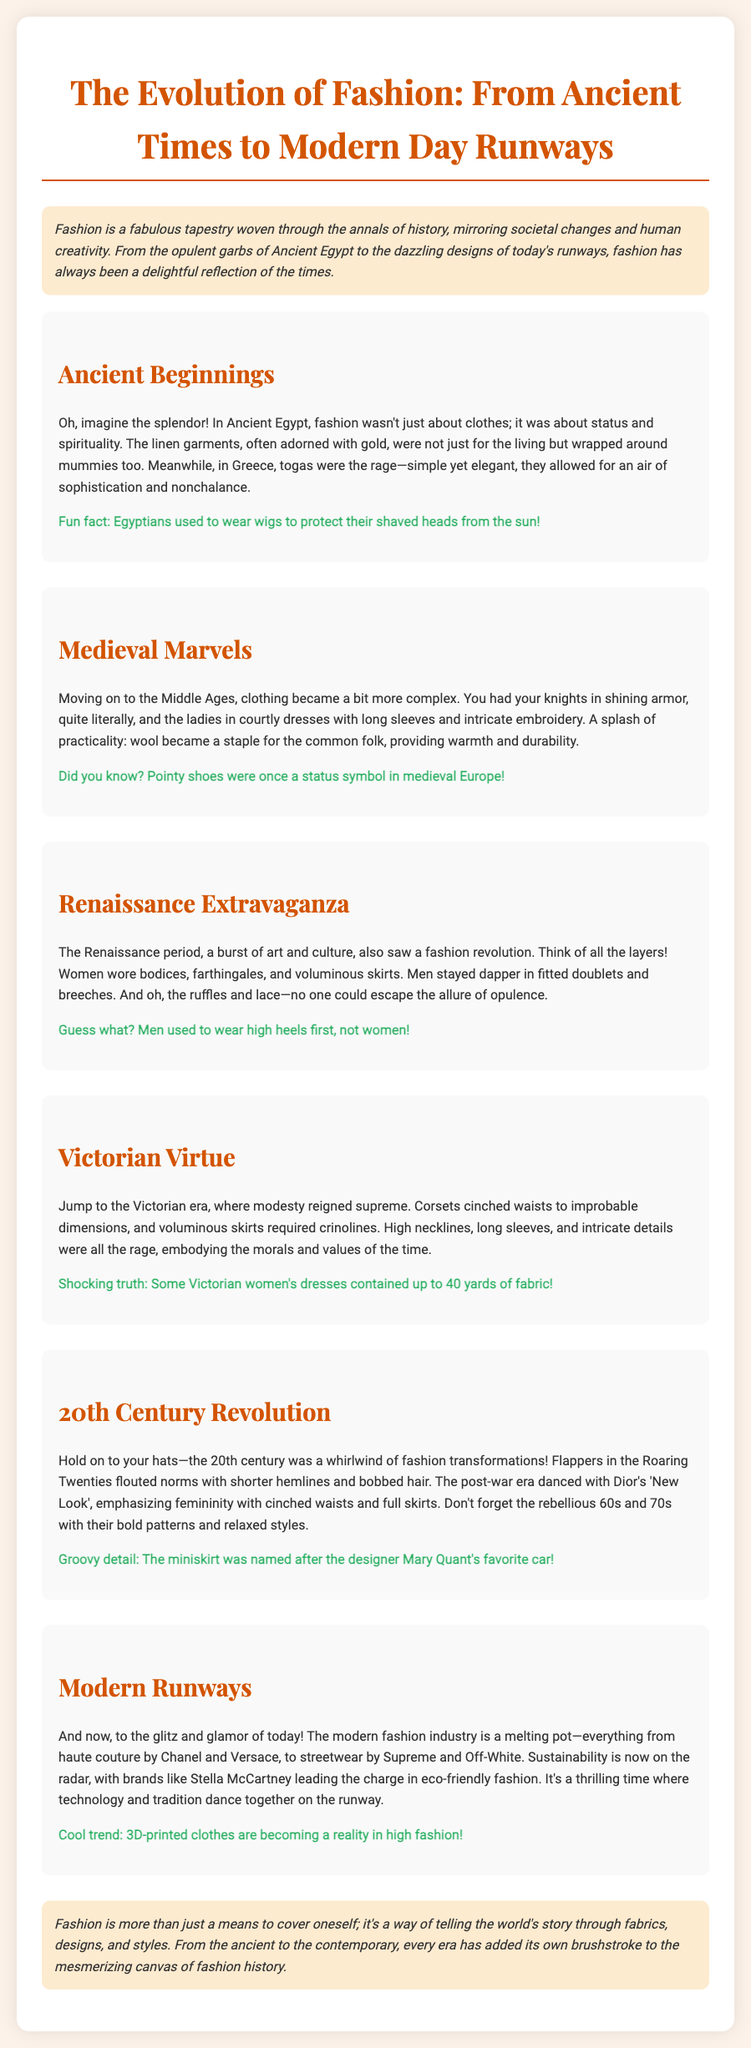What was a unique feature of Ancient Egyptian fashion? Ancient Egyptian fashion was not just about clothes; it was about status and spirituality.
Answer: Status and spirituality What fabric was commonly used in Ancient Egyptian garments? The document mentions that linen garments were often used in Ancient Egypt.
Answer: Linen What is a fun fact about wigs in Ancient Egypt? The fun fact states that Egyptians used to wear wigs to protect their shaved heads from the sun.
Answer: Protect their shaved heads from the sun Which era is known for the use of corsets? The Victorian era is characterized by the use of corsets to cinch waists.
Answer: Victorian era What fashion trend emerged during the Roaring Twenties? The document states that flappers in the Roaring Twenties flouted norms with shorter hemlines and bobbed hair.
Answer: Shorter hemlines What did the Renaissance period see in terms of male fashion? Men during the Renaissance stayed dapper in fitted doublets and breeches.
Answer: Fitted doublets and breeches How much fabric could some Victorian dresses contain? The document reveals that some Victorian women's dresses contained up to 40 yards of fabric.
Answer: Up to 40 yards What is an emerging trend in modern fashion? The document mentions that 3D-printed clothes are becoming a reality in high fashion.
Answer: 3D-printed clothes What notable characteristic defined medieval clothing? Medieval clothing became more complex with intricate embroidery and pointed shoes as a status symbol.
Answer: Complex with intricate embroidery Who is associated with the 'New Look' in fashion? The post-war era signifies Dior's 'New Look', emphasizing femininity.
Answer: Dior 